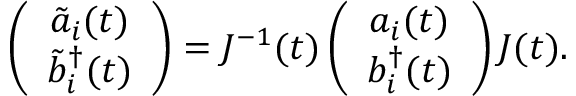Convert formula to latex. <formula><loc_0><loc_0><loc_500><loc_500>\left ( \begin{array} { c } { { \tilde { a } _ { i } ( t ) } } \\ { { \tilde { b } _ { i } ^ { \dagger } ( t ) } } \end{array} \right ) = J ^ { - 1 } ( t ) \left ( \begin{array} { c } { { a _ { i } ( t ) } } \\ { { b _ { i } ^ { \dagger } ( t ) } } \end{array} \right ) J ( t ) .</formula> 